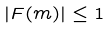<formula> <loc_0><loc_0><loc_500><loc_500>| F ( m ) | \leq 1</formula> 